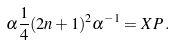<formula> <loc_0><loc_0><loc_500><loc_500>\alpha \frac { 1 } { 4 } ( 2 n + 1 ) ^ { 2 } \alpha ^ { - 1 } = X P \, .</formula> 